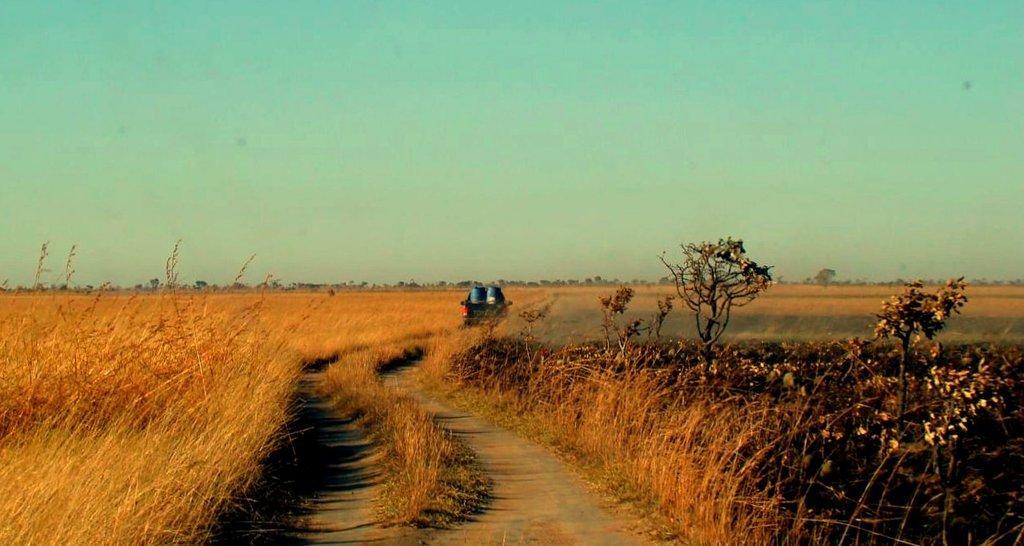In one or two sentences, can you explain what this image depicts? We can see grass,plants and trees. We can see vehicle on the surface. In the background we can see trees and sky. 